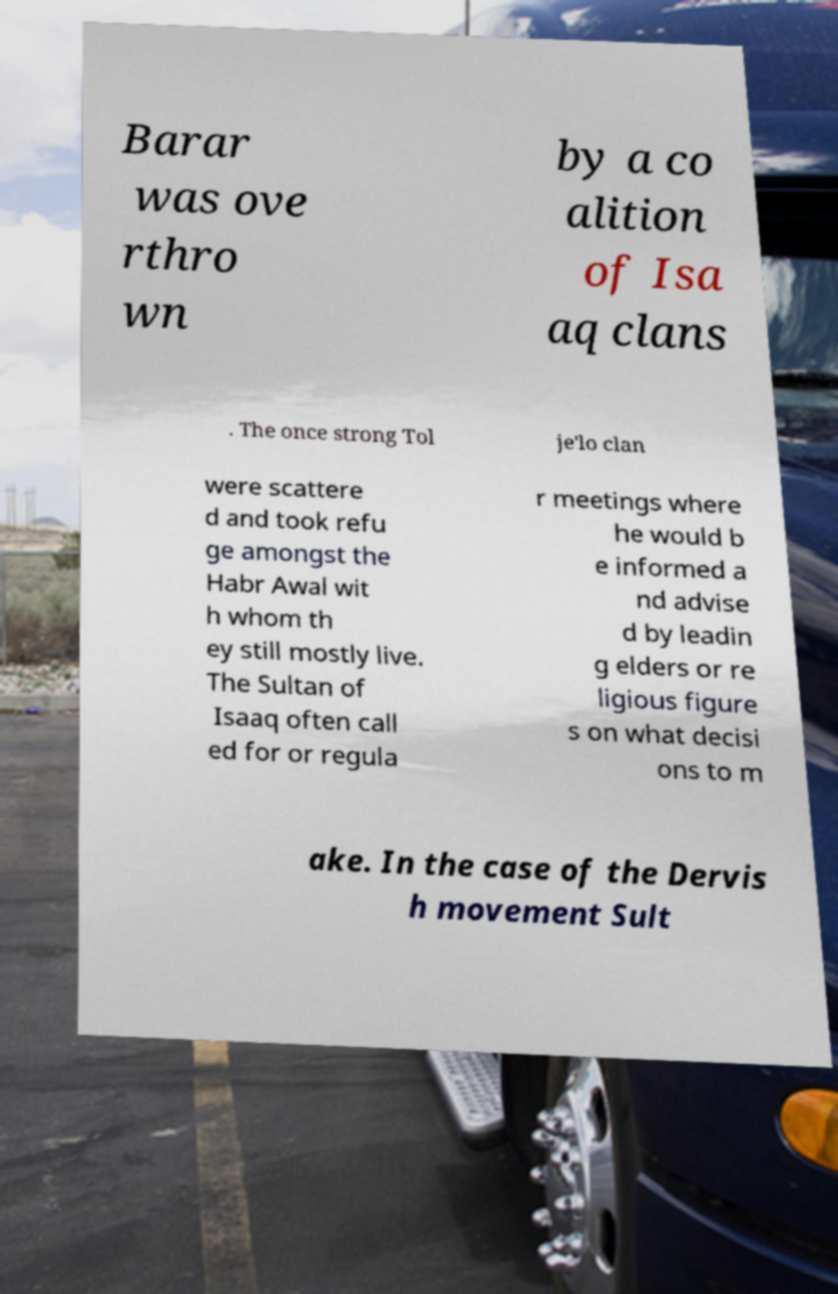Could you extract and type out the text from this image? Barar was ove rthro wn by a co alition of Isa aq clans . The once strong Tol je'lo clan were scattere d and took refu ge amongst the Habr Awal wit h whom th ey still mostly live. The Sultan of Isaaq often call ed for or regula r meetings where he would b e informed a nd advise d by leadin g elders or re ligious figure s on what decisi ons to m ake. In the case of the Dervis h movement Sult 